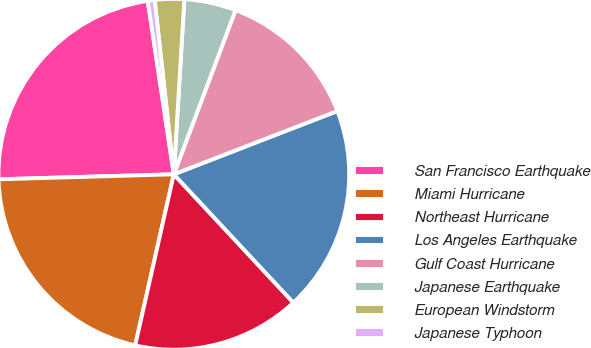Convert chart to OTSL. <chart><loc_0><loc_0><loc_500><loc_500><pie_chart><fcel>San Francisco Earthquake<fcel>Miami Hurricane<fcel>Northeast Hurricane<fcel>Los Angeles Earthquake<fcel>Gulf Coast Hurricane<fcel>Japanese Earthquake<fcel>European Windstorm<fcel>Japanese Typhoon<nl><fcel>23.08%<fcel>21.01%<fcel>15.47%<fcel>18.94%<fcel>13.4%<fcel>4.77%<fcel>2.7%<fcel>0.63%<nl></chart> 